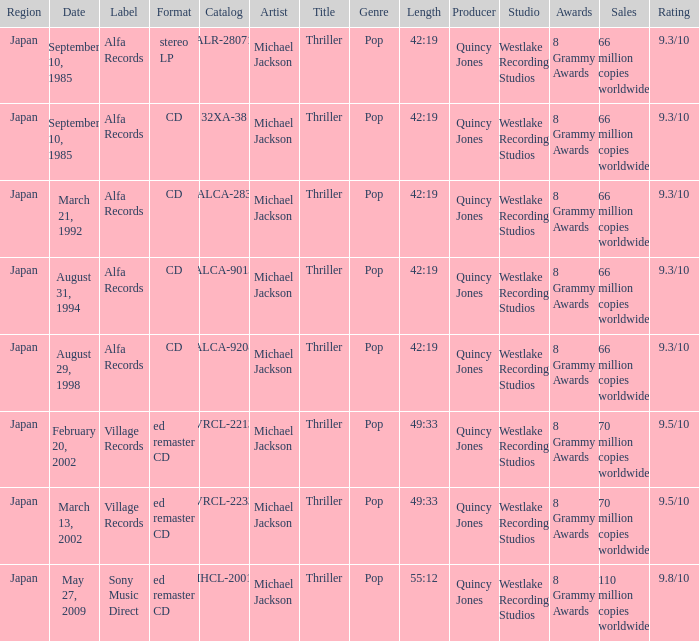Which catalog was organized as a cd under the alfa records brand? 32XA-38, ALCA-283, ALCA-9013, ALCA-9208. 